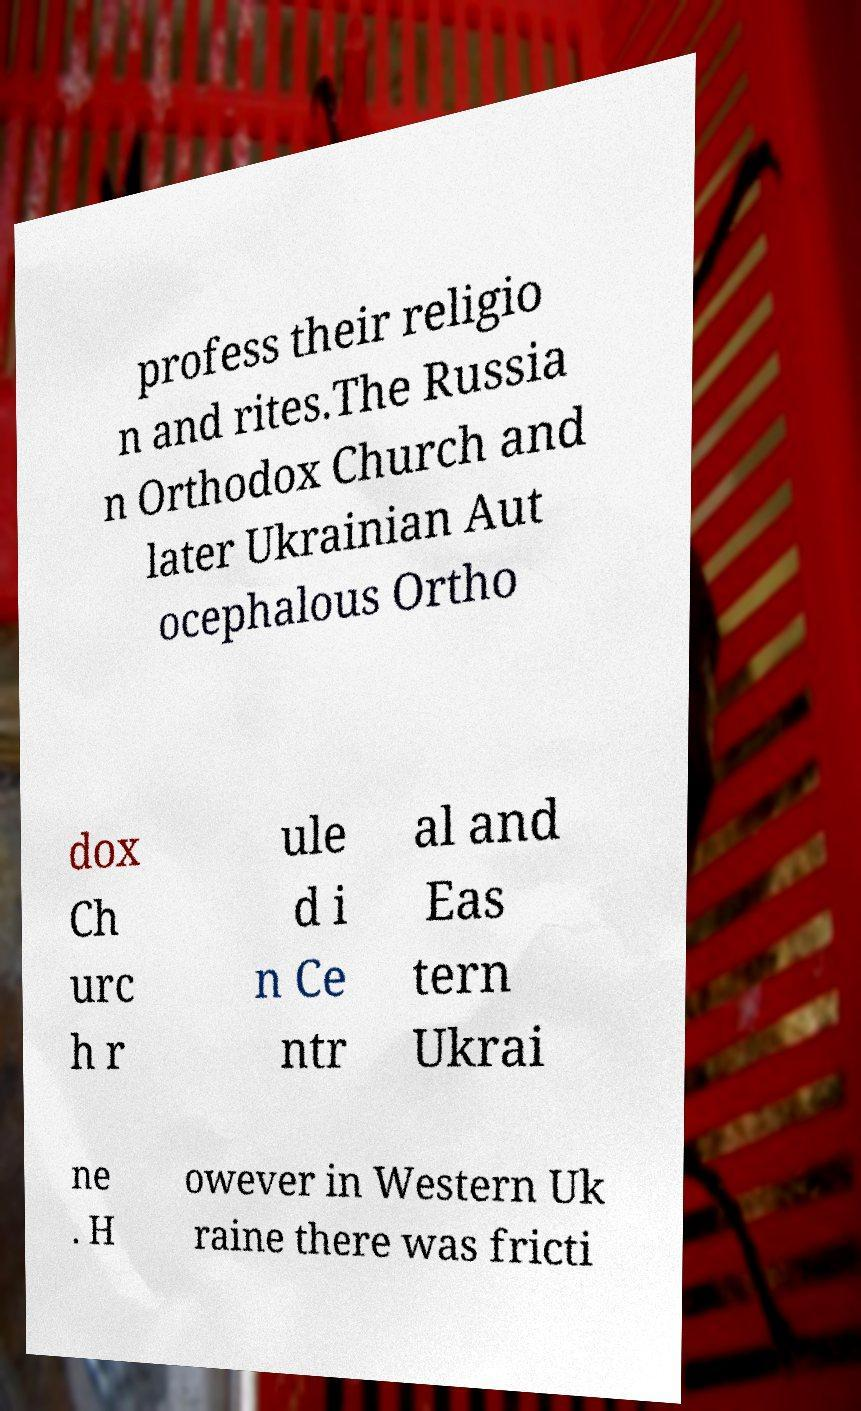Please read and relay the text visible in this image. What does it say? profess their religio n and rites.The Russia n Orthodox Church and later Ukrainian Aut ocephalous Ortho dox Ch urc h r ule d i n Ce ntr al and Eas tern Ukrai ne . H owever in Western Uk raine there was fricti 